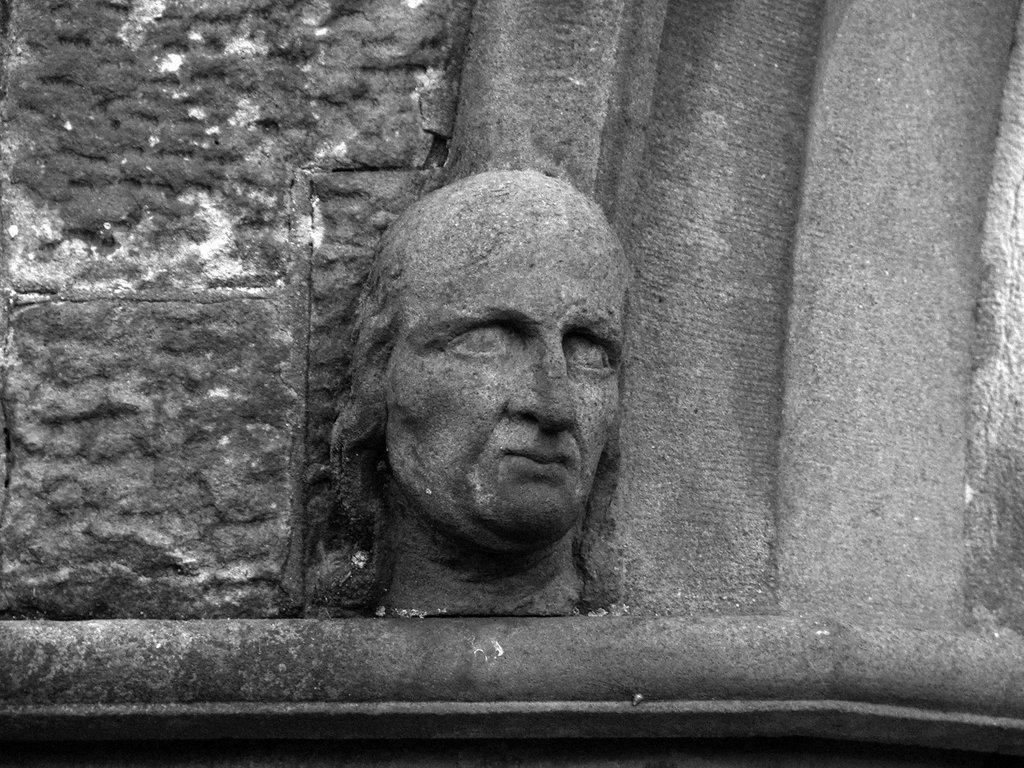What is the main subject in the center of the image? There is a sculpture in the center of the image. What can be seen in the background of the image? There is a wall in the background of the image. Where is the rail for the popcorn machine located in the image? There is no rail or popcorn machine present in the image. What type of field can be seen in the image? There is no field present in the image; it features a sculpture and a wall. 